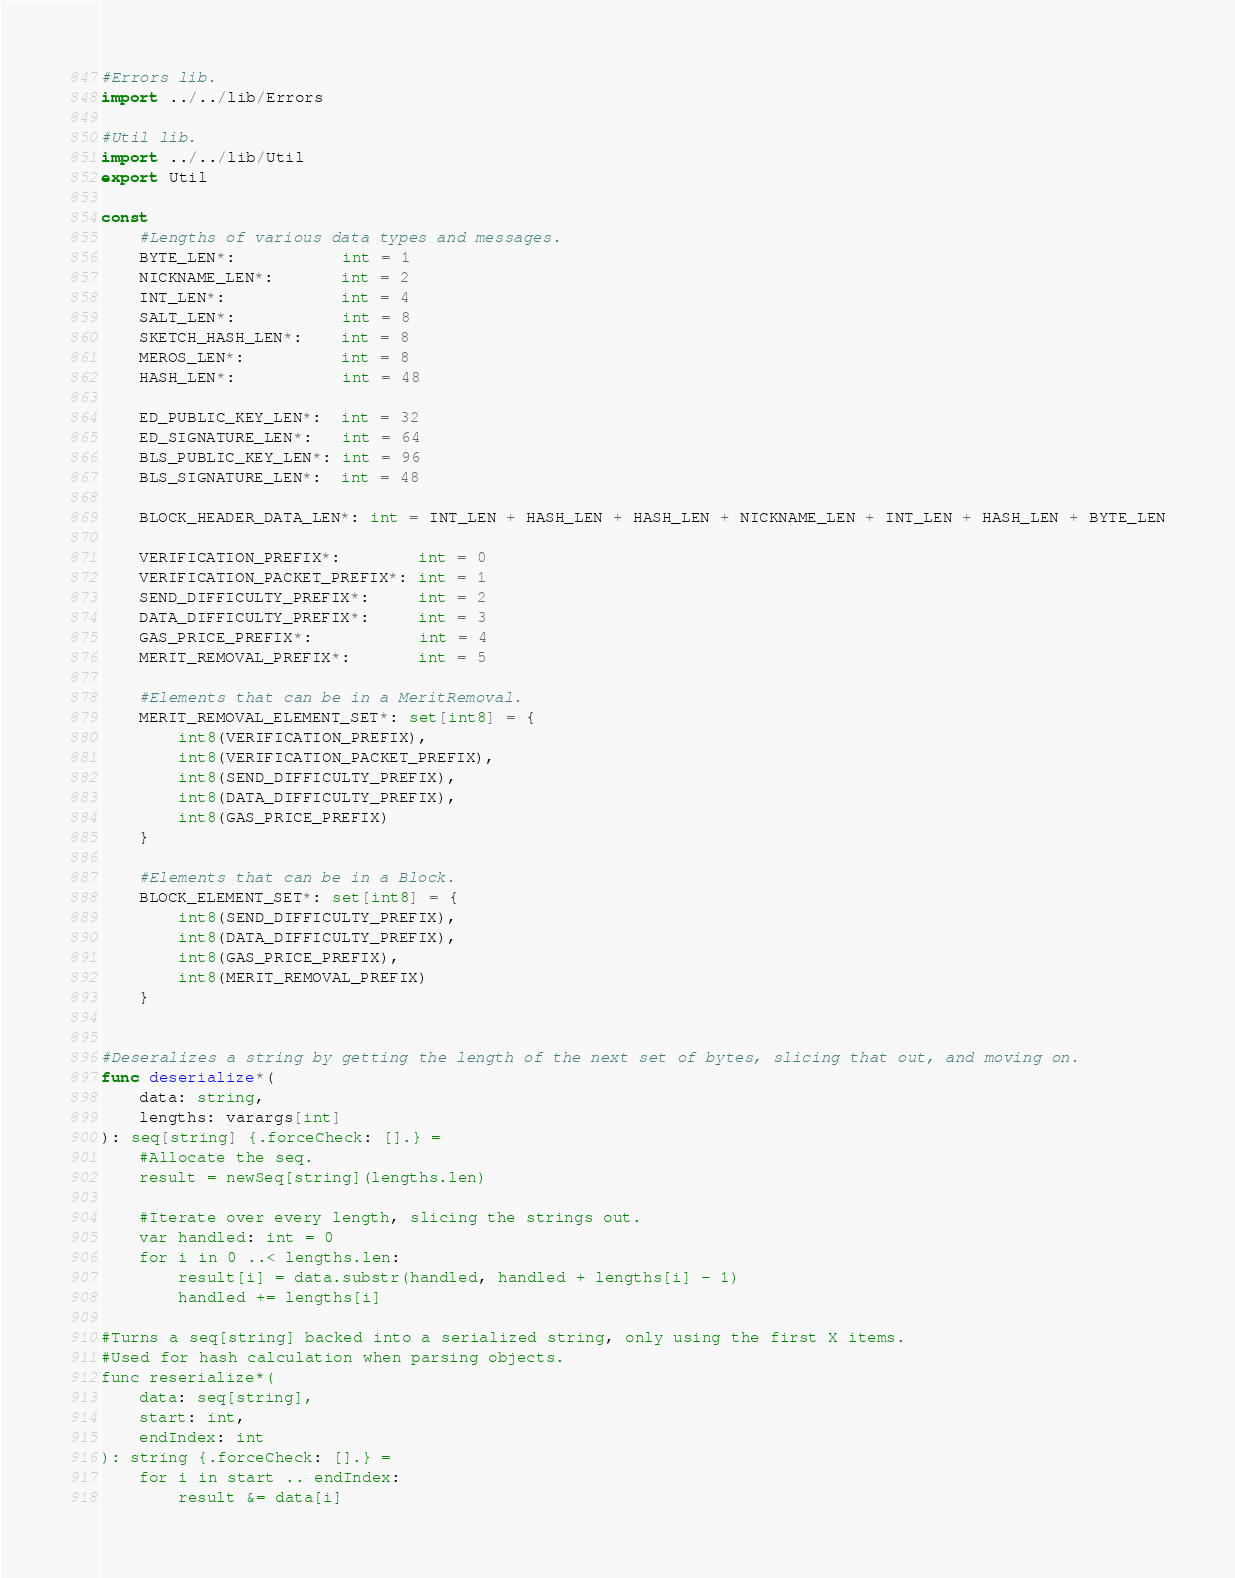<code> <loc_0><loc_0><loc_500><loc_500><_Nim_>#Errors lib.
import ../../lib/Errors

#Util lib.
import ../../lib/Util
export Util

const
    #Lengths of various data types and messages.
    BYTE_LEN*:           int = 1
    NICKNAME_LEN*:       int = 2
    INT_LEN*:            int = 4
    SALT_LEN*:           int = 8
    SKETCH_HASH_LEN*:    int = 8
    MEROS_LEN*:          int = 8
    HASH_LEN*:           int = 48

    ED_PUBLIC_KEY_LEN*:  int = 32
    ED_SIGNATURE_LEN*:   int = 64
    BLS_PUBLIC_KEY_LEN*: int = 96
    BLS_SIGNATURE_LEN*:  int = 48

    BLOCK_HEADER_DATA_LEN*: int = INT_LEN + HASH_LEN + HASH_LEN + NICKNAME_LEN + INT_LEN + HASH_LEN + BYTE_LEN

    VERIFICATION_PREFIX*:        int = 0
    VERIFICATION_PACKET_PREFIX*: int = 1
    SEND_DIFFICULTY_PREFIX*:     int = 2
    DATA_DIFFICULTY_PREFIX*:     int = 3
    GAS_PRICE_PREFIX*:           int = 4
    MERIT_REMOVAL_PREFIX*:       int = 5

    #Elements that can be in a MeritRemoval.
    MERIT_REMOVAL_ELEMENT_SET*: set[int8] = {
        int8(VERIFICATION_PREFIX),
        int8(VERIFICATION_PACKET_PREFIX),
        int8(SEND_DIFFICULTY_PREFIX),
        int8(DATA_DIFFICULTY_PREFIX),
        int8(GAS_PRICE_PREFIX)
    }

    #Elements that can be in a Block.
    BLOCK_ELEMENT_SET*: set[int8] = {
        int8(SEND_DIFFICULTY_PREFIX),
        int8(DATA_DIFFICULTY_PREFIX),
        int8(GAS_PRICE_PREFIX),
        int8(MERIT_REMOVAL_PREFIX)
    }


#Deseralizes a string by getting the length of the next set of bytes, slicing that out, and moving on.
func deserialize*(
    data: string,
    lengths: varargs[int]
): seq[string] {.forceCheck: [].} =
    #Allocate the seq.
    result = newSeq[string](lengths.len)

    #Iterate over every length, slicing the strings out.
    var handled: int = 0
    for i in 0 ..< lengths.len:
        result[i] = data.substr(handled, handled + lengths[i] - 1)
        handled += lengths[i]

#Turns a seq[string] backed into a serialized string, only using the first X items.
#Used for hash calculation when parsing objects.
func reserialize*(
    data: seq[string],
    start: int,
    endIndex: int
): string {.forceCheck: [].} =
    for i in start .. endIndex:
        result &= data[i]
</code> 